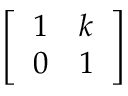Convert formula to latex. <formula><loc_0><loc_0><loc_500><loc_500>\left [ \begin{array} { l l } { 1 } & { k } \\ { 0 } & { 1 } \end{array} \right ]</formula> 